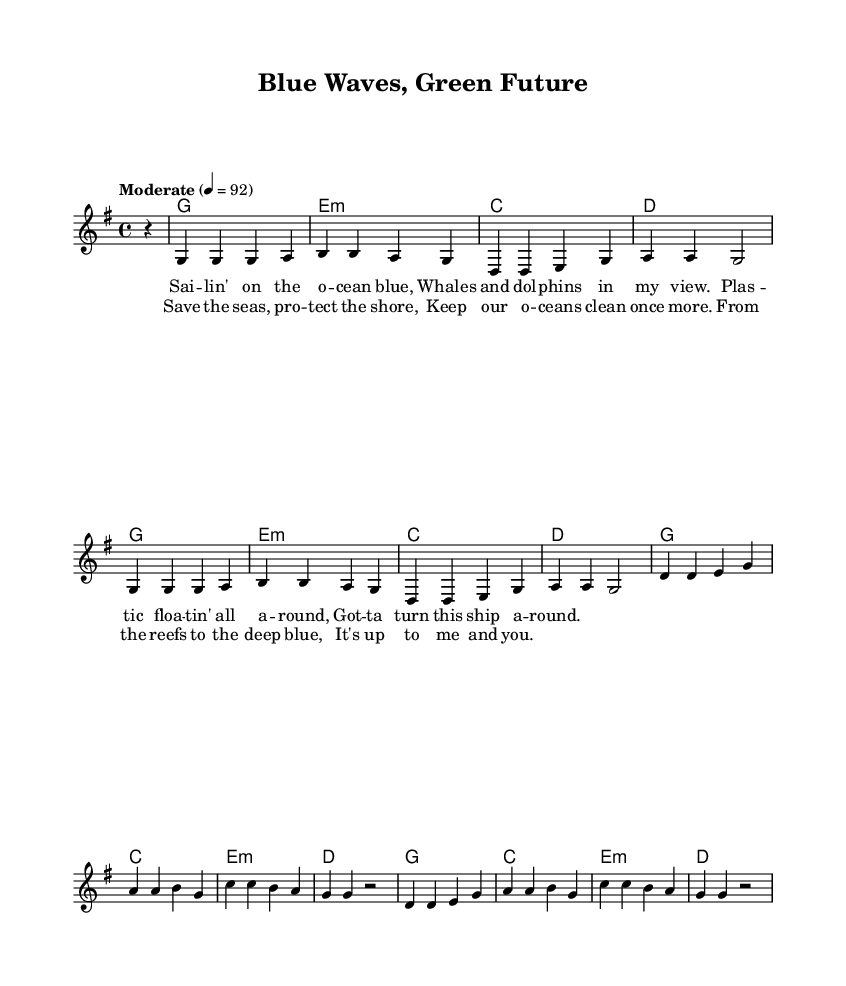What is the key signature of this music? The key signature is G major, which has one sharp (F#). This can be identified by looking at the key signature notation at the beginning of the staff.
Answer: G major What is the time signature of this music? The time signature is 4/4, which means there are four beats in each measure and a quarter note gets one beat. This is indicated at the beginning of the score where the time signature is written.
Answer: 4/4 What is the tempo marking of this piece? The tempo marking indicates "Moderate" at a speed of 92 beats per minute. This is usually found near the top of the score and specifies the speed at which the piece should be played.
Answer: Moderate 4 = 92 How many measures are there in the chorus section? The chorus consists of 4 measures, as indicated by the lyrics under the melody, which are divided into the respective measures. Each line of lyrics corresponds to a measure in the melody.
Answer: 4 Which chord follows the melody in the second measure of the verse? The chord that follows the melody in the second measure of the verse is B, as indicated in the chord notation. The chords are provided in the score alongside the melody and lyrics.
Answer: B What is the main theme of the lyrics presented in this sheet music? The main theme of the lyrics centers around ocean conservation and the protection of marine life, as suggested by phrases like "Save the seas" and "protect the shore." This overall message is reflected through the content and intent of the lyrics.
Answer: Ocean conservation Which harmonic quality is primarily used throughout this piece? The harmonic quality prominently utilized is major chords, as seen with the presence of G major, C major, and D major, which create a bright and uplifting sound typical for country songs. This can be inferred by recognizing the chord symbols used.
Answer: Major chords 